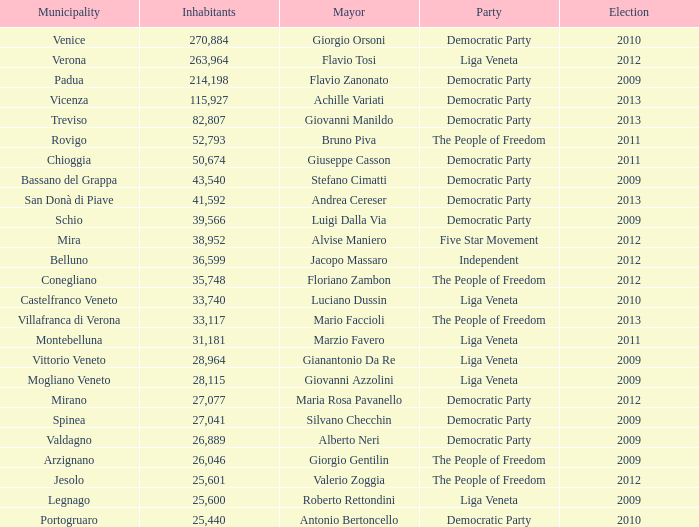In the election earlier than 2012 how many Inhabitants had a Party of five star movement? None. 